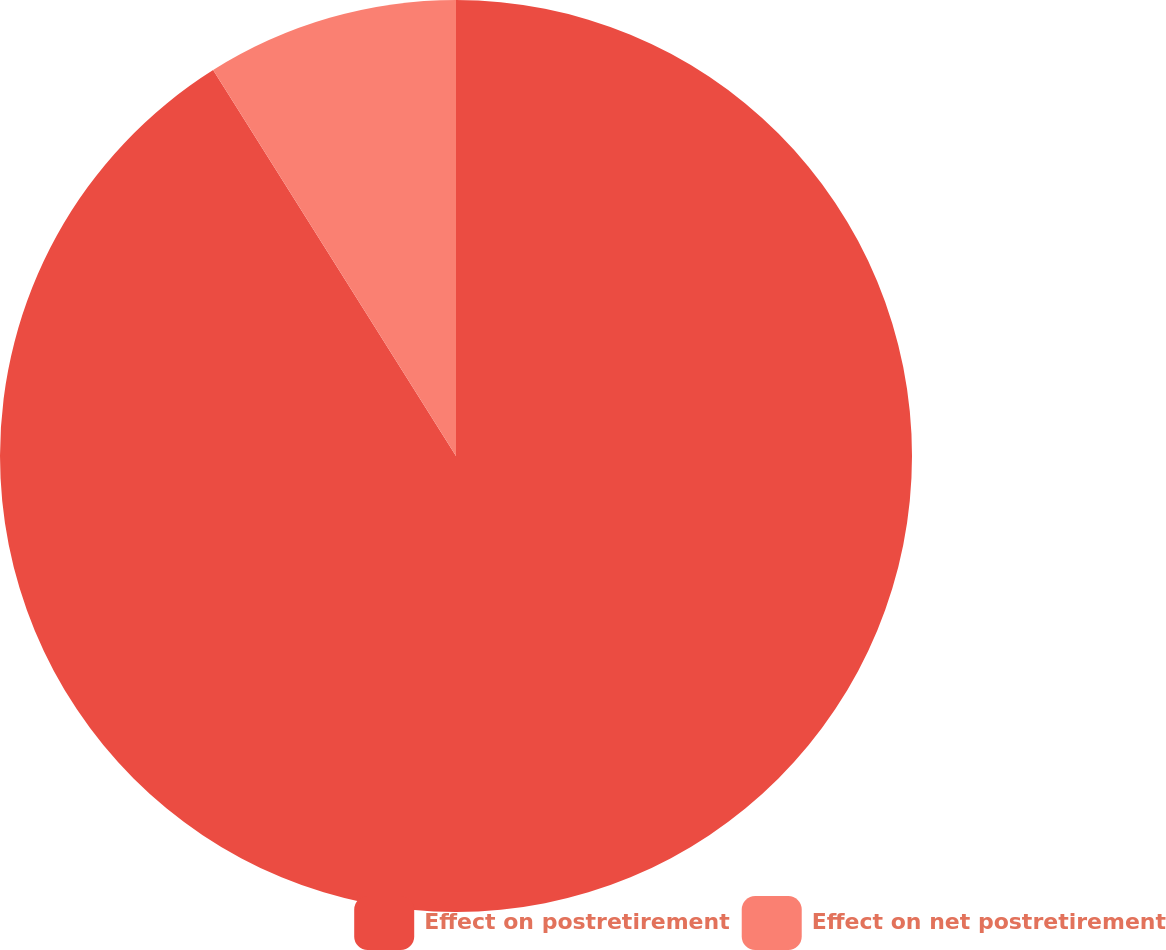Convert chart to OTSL. <chart><loc_0><loc_0><loc_500><loc_500><pie_chart><fcel>Effect on postretirement<fcel>Effect on net postretirement<nl><fcel>91.06%<fcel>8.94%<nl></chart> 